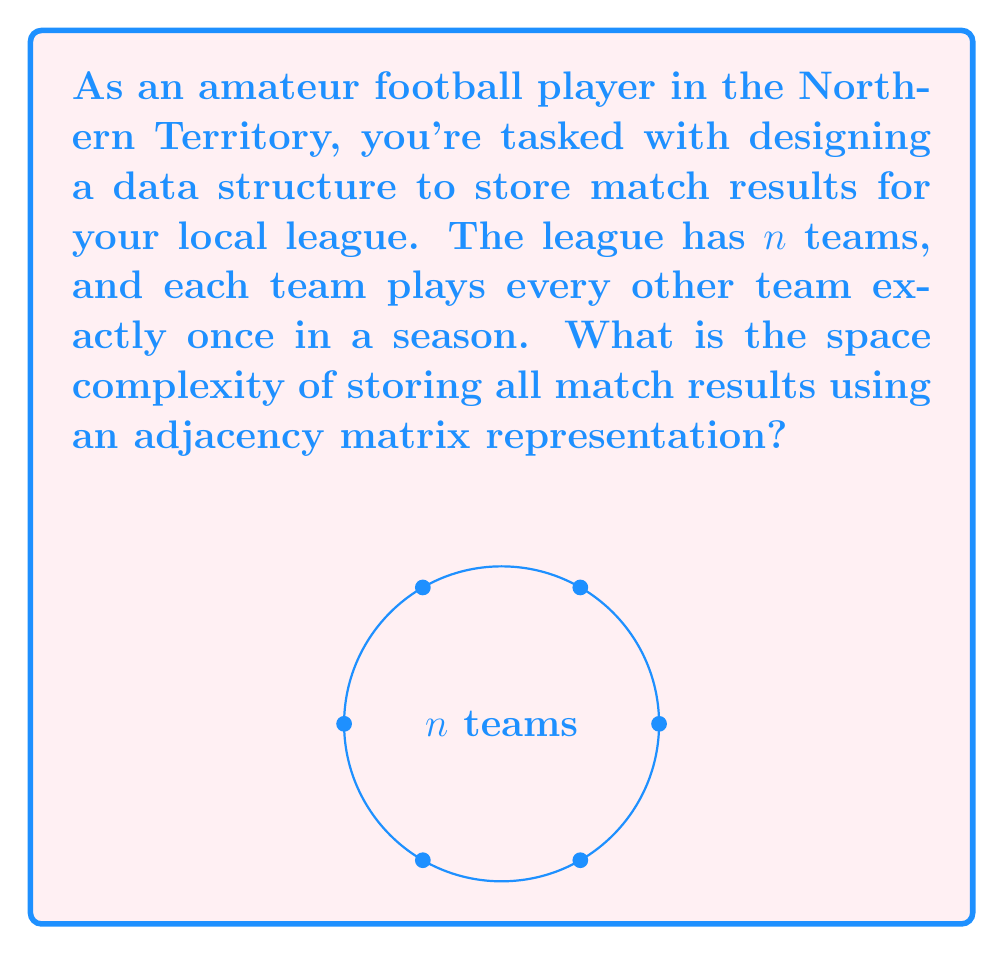Give your solution to this math problem. Let's approach this step-by-step:

1) In a league where each team plays every other team once, we have a complete graph structure.

2) The number of matches in a season can be calculated as:
   $\text{Number of matches} = \frac{n(n-1)}{2}$

3) An adjacency matrix for a graph with $n$ vertices is an $n \times n$ matrix.

4) In our case, each cell of the matrix could store the result of a match between two teams.

5) The space required for an $n \times n$ matrix is $n^2$.

6) Even though we only need to store half of the matrix (excluding the diagonal) due to the symmetry of matches, in terms of asymptotic complexity, this doesn't change the overall space complexity.

7) Therefore, the space complexity of storing all match results using an adjacency matrix is $O(n^2)$.

8) This quadratic space complexity means that as the number of teams increases, the space required grows quadratically.
Answer: $O(n^2)$ 